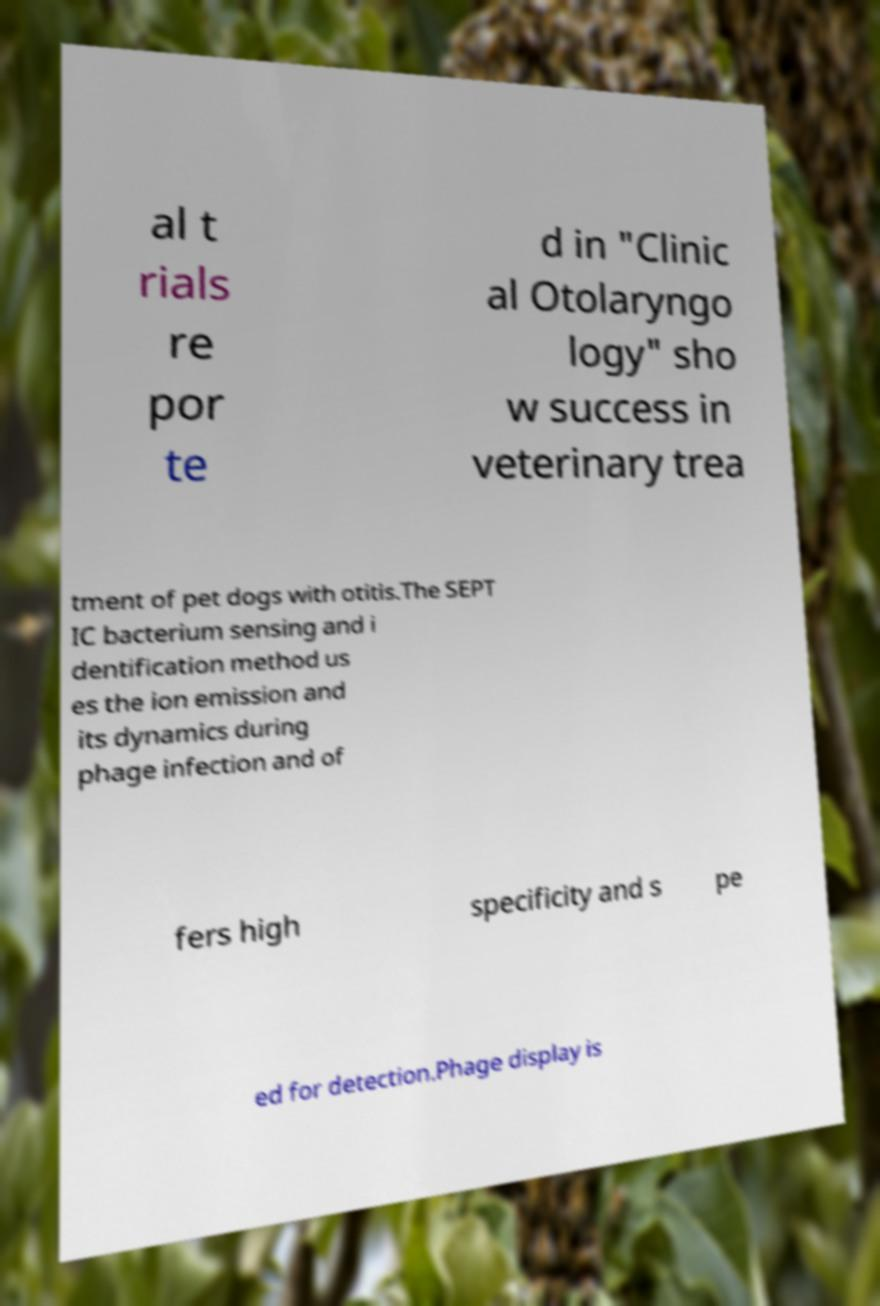Can you accurately transcribe the text from the provided image for me? al t rials re por te d in "Clinic al Otolaryngo logy" sho w success in veterinary trea tment of pet dogs with otitis.The SEPT IC bacterium sensing and i dentification method us es the ion emission and its dynamics during phage infection and of fers high specificity and s pe ed for detection.Phage display is 